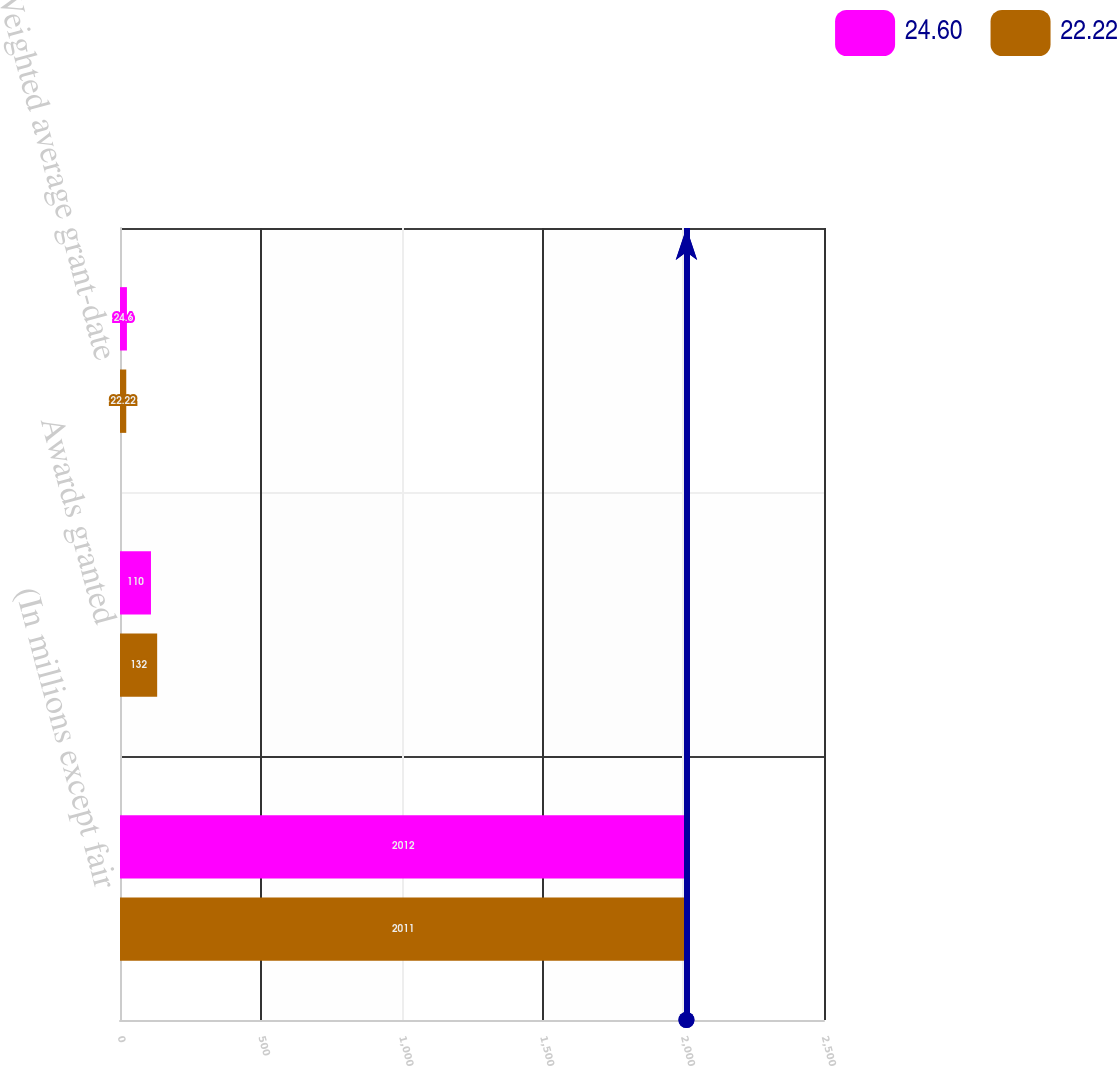Convert chart to OTSL. <chart><loc_0><loc_0><loc_500><loc_500><stacked_bar_chart><ecel><fcel>(In millions except fair<fcel>Awards granted<fcel>Weighted average grant-date<nl><fcel>24.6<fcel>2012<fcel>110<fcel>24.6<nl><fcel>22.22<fcel>2011<fcel>132<fcel>22.22<nl></chart> 